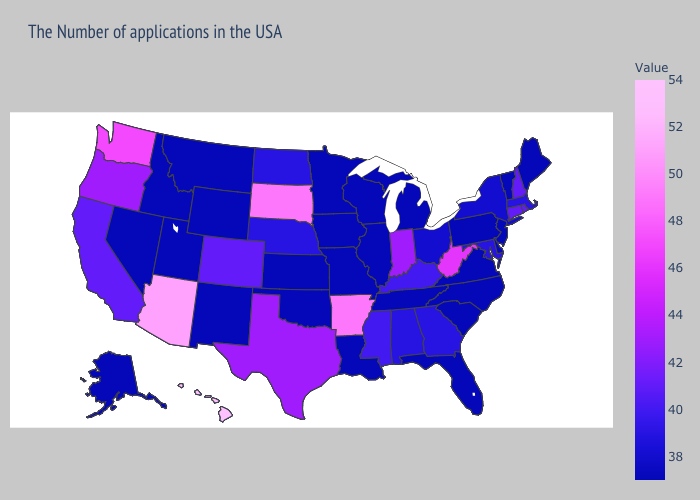Among the states that border Arkansas , which have the highest value?
Give a very brief answer. Texas. Does Hawaii have the highest value in the USA?
Quick response, please. Yes. Which states have the lowest value in the USA?
Quick response, please. Maine, Vermont, New Jersey, Delaware, Pennsylvania, Virginia, North Carolina, South Carolina, Florida, Michigan, Tennessee, Wisconsin, Illinois, Louisiana, Missouri, Minnesota, Iowa, Kansas, Oklahoma, Wyoming, New Mexico, Utah, Montana, Idaho, Nevada, Alaska. Does New Mexico have the lowest value in the West?
Write a very short answer. Yes. Does Nevada have the highest value in the West?
Answer briefly. No. Does Hawaii have the highest value in the USA?
Give a very brief answer. Yes. Which states have the highest value in the USA?
Be succinct. Hawaii. Does Wisconsin have the lowest value in the USA?
Quick response, please. Yes. 